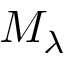Convert formula to latex. <formula><loc_0><loc_0><loc_500><loc_500>M _ { \lambda }</formula> 